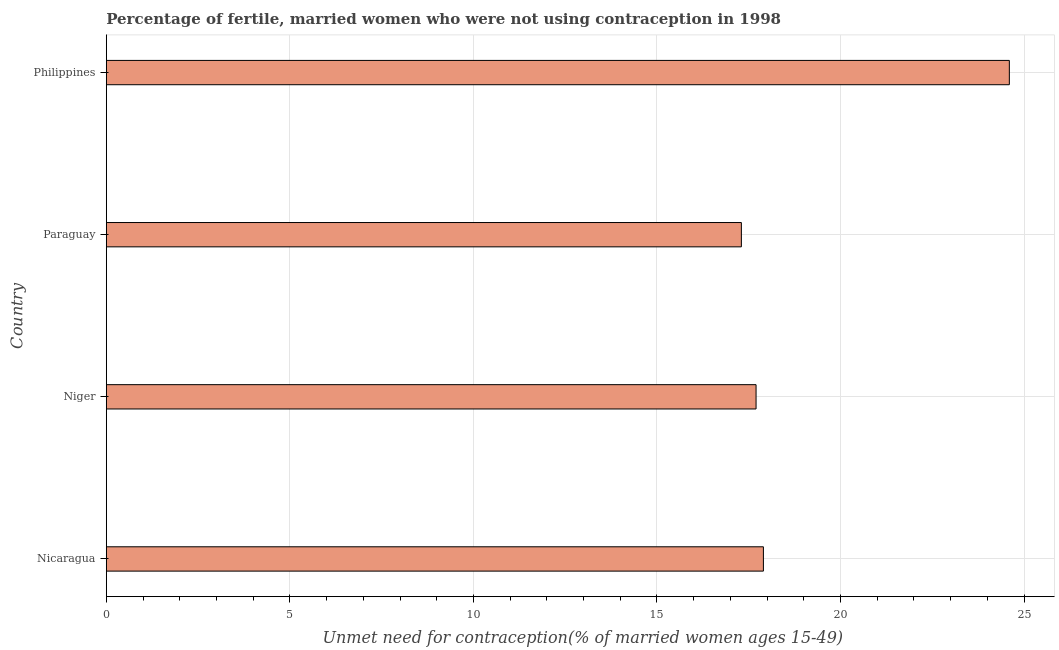Does the graph contain grids?
Ensure brevity in your answer.  Yes. What is the title of the graph?
Give a very brief answer. Percentage of fertile, married women who were not using contraception in 1998. What is the label or title of the X-axis?
Keep it short and to the point.  Unmet need for contraception(% of married women ages 15-49). What is the label or title of the Y-axis?
Provide a short and direct response. Country. Across all countries, what is the maximum number of married women who are not using contraception?
Your response must be concise. 24.6. Across all countries, what is the minimum number of married women who are not using contraception?
Give a very brief answer. 17.3. In which country was the number of married women who are not using contraception minimum?
Keep it short and to the point. Paraguay. What is the sum of the number of married women who are not using contraception?
Give a very brief answer. 77.5. What is the average number of married women who are not using contraception per country?
Make the answer very short. 19.38. What is the median number of married women who are not using contraception?
Your response must be concise. 17.8. What is the ratio of the number of married women who are not using contraception in Niger to that in Philippines?
Provide a short and direct response. 0.72. What is the difference between the highest and the second highest number of married women who are not using contraception?
Keep it short and to the point. 6.7. Is the sum of the number of married women who are not using contraception in Nicaragua and Paraguay greater than the maximum number of married women who are not using contraception across all countries?
Make the answer very short. Yes. Are all the bars in the graph horizontal?
Make the answer very short. Yes. How many countries are there in the graph?
Keep it short and to the point. 4. Are the values on the major ticks of X-axis written in scientific E-notation?
Offer a terse response. No. What is the  Unmet need for contraception(% of married women ages 15-49) in Niger?
Provide a short and direct response. 17.7. What is the  Unmet need for contraception(% of married women ages 15-49) in Paraguay?
Your answer should be compact. 17.3. What is the  Unmet need for contraception(% of married women ages 15-49) in Philippines?
Your answer should be compact. 24.6. What is the difference between the  Unmet need for contraception(% of married women ages 15-49) in Nicaragua and Philippines?
Keep it short and to the point. -6.7. What is the difference between the  Unmet need for contraception(% of married women ages 15-49) in Paraguay and Philippines?
Your response must be concise. -7.3. What is the ratio of the  Unmet need for contraception(% of married women ages 15-49) in Nicaragua to that in Paraguay?
Provide a succinct answer. 1.03. What is the ratio of the  Unmet need for contraception(% of married women ages 15-49) in Nicaragua to that in Philippines?
Give a very brief answer. 0.73. What is the ratio of the  Unmet need for contraception(% of married women ages 15-49) in Niger to that in Philippines?
Keep it short and to the point. 0.72. What is the ratio of the  Unmet need for contraception(% of married women ages 15-49) in Paraguay to that in Philippines?
Offer a very short reply. 0.7. 